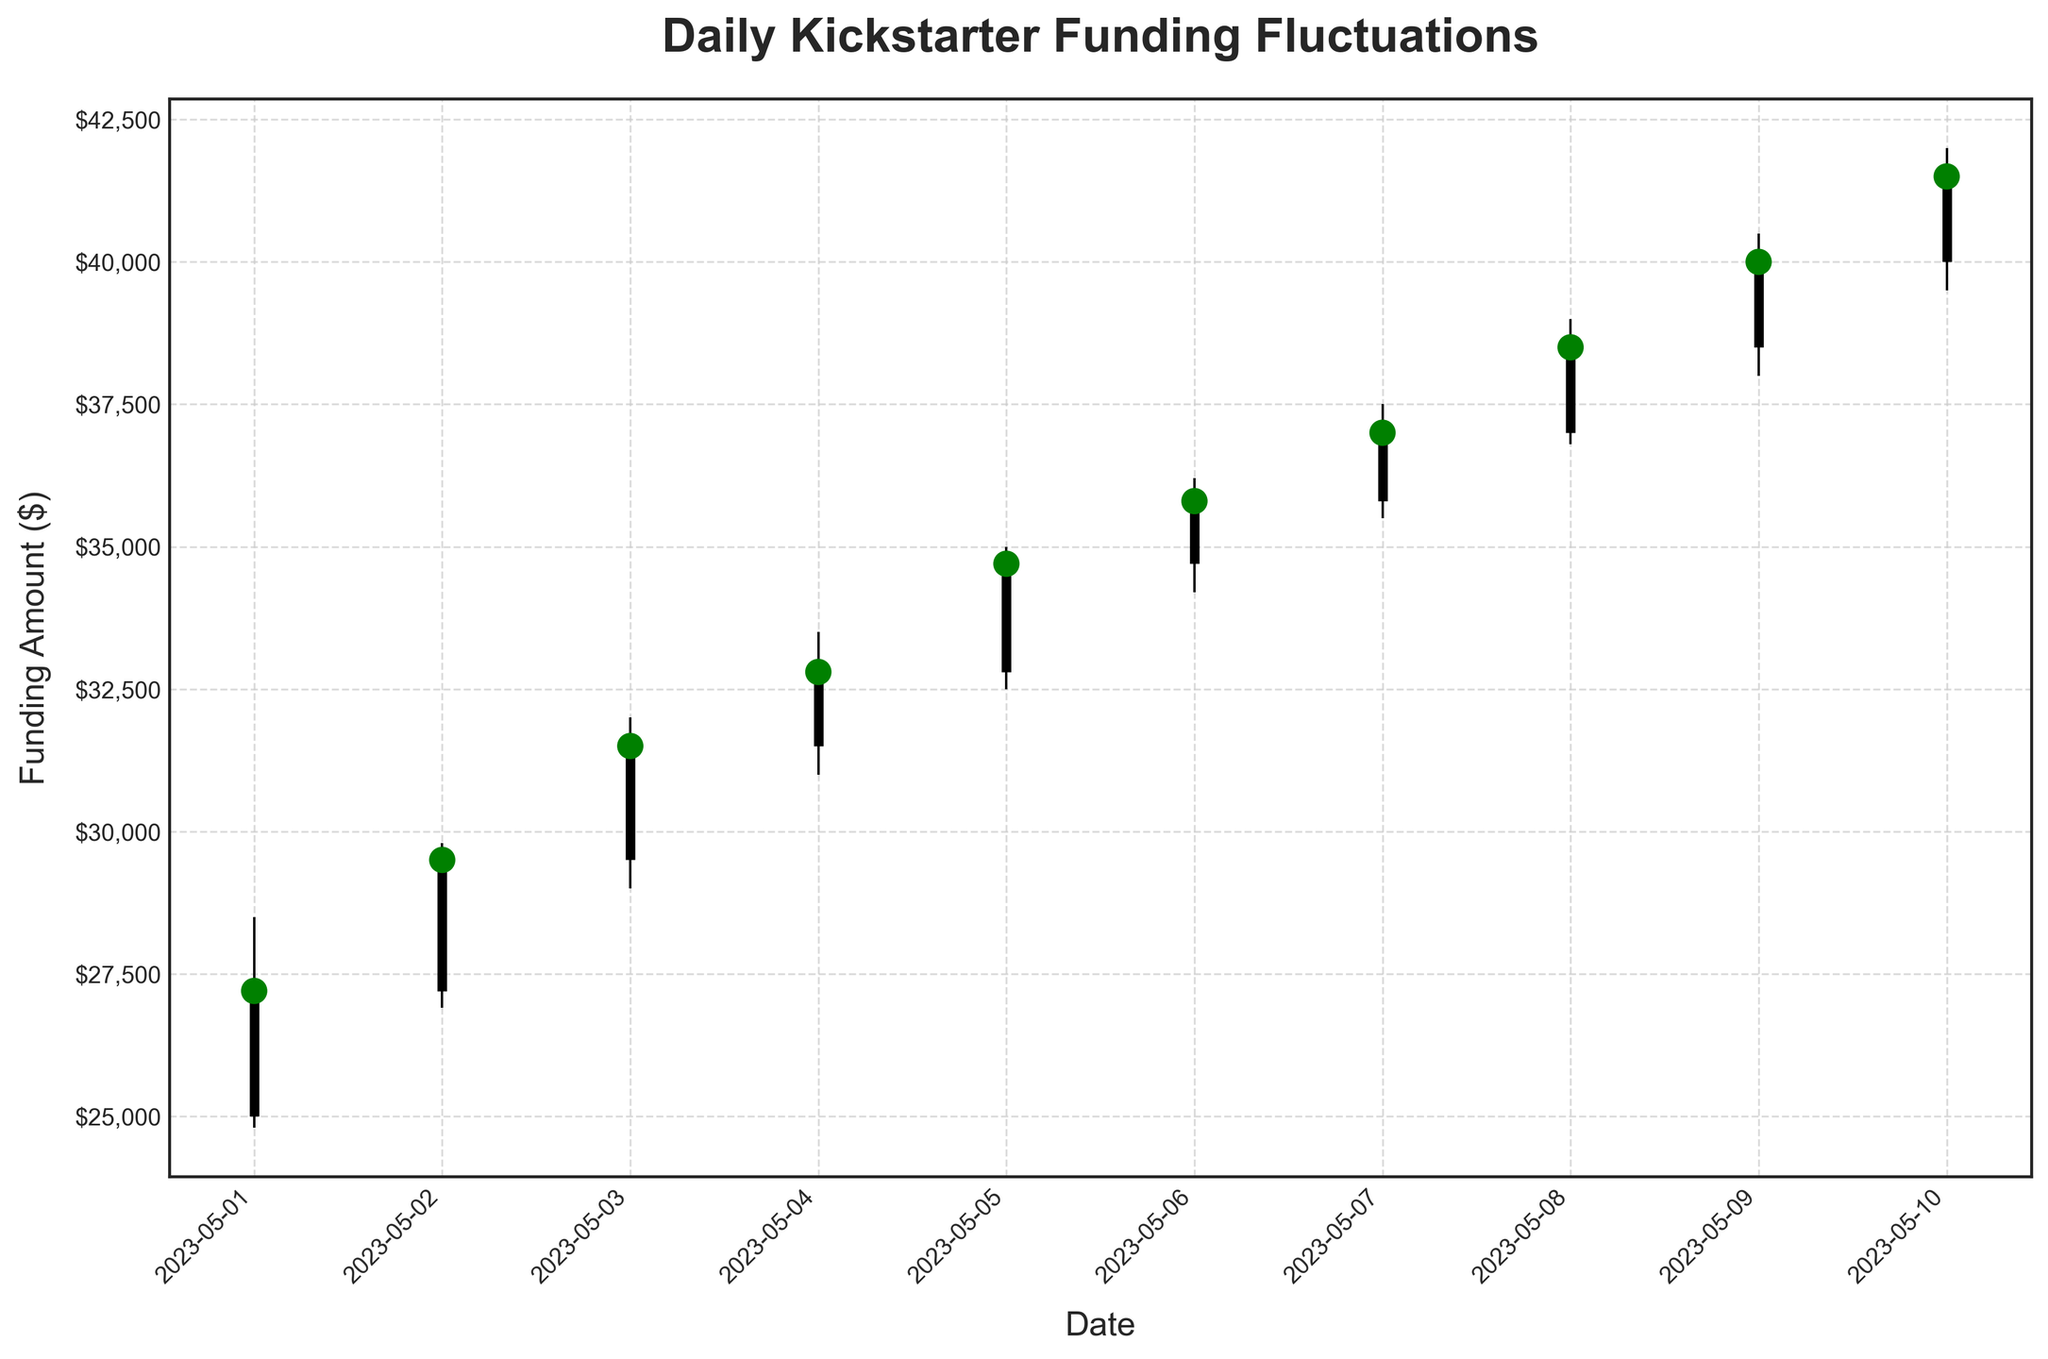What's the title of the chart? The chart's title is typically found at the top and is written in larger and bold font to indicate what the chart is about.
Answer: Daily Kickstarter Funding Fluctuations What is the highest funding amount recorded in the chart and on which date? The highest funding amount is the peak of the wicks (High values) on the OHLC bars. Look at the top ends of the vertical lines to find the maximum value, then check the corresponding date.
Answer: $42,000 on 2023-05-10 What color are the closing points when the closing price is higher than the opening price? In the OHLC charts, the color of closing points often indicates whether the closing price is higher (e.g., using green) or lower (e.g., using red) than the opening price.
Answer: Green How many days had the closing funding amount higher than the opening amount? To determine this, count the number of green points, which signify the closing amount is higher than the opening amount. Each green point represents such an instance.
Answer: 10 days What's the general trend of the funding amounts over the 10-day period? Observing the chart from left to right, if the closing prices generally increase over time, the trend is upward. If they decrease, the trend is downward.
Answer: Upward What's the difference between the highest closing and the lowest closing funding amounts? The highest closing funding amount is at the top-most closing point, and the lowest closing funding amount is at the bottom-most closing point. Calculate the difference between these amounts.
Answer: $41,500 - $27,200 = $14,300 On which date did the most significant increase in the closing funding amount occur compared to the previous day? This requires checking the difference in closing amounts day by day and identifying the day with the largest positive difference between consecutive days.
Answer: 2023-05-09 Compare the funding on May 5th and May 8th. Did the funding increase or decrease? Check the closing amount on May 5th and May 8th and see whether the closing value on May 8th is higher or lower than on May 5th.
Answer: Increase What is the range of funding amounts on May 6th? The range is determined by subtracting the low funding amount from the high funding amount for May 6th. Identify the values and calculate the difference.
Answer: $36,200 - $34,200 = $2,000 Was there any day when the closing amount was equal to the high funding amount of the day? If so, which day(s)? This involves checking each day to see if the closing value matches the highest point (High value) of that day.
Answer: No days 